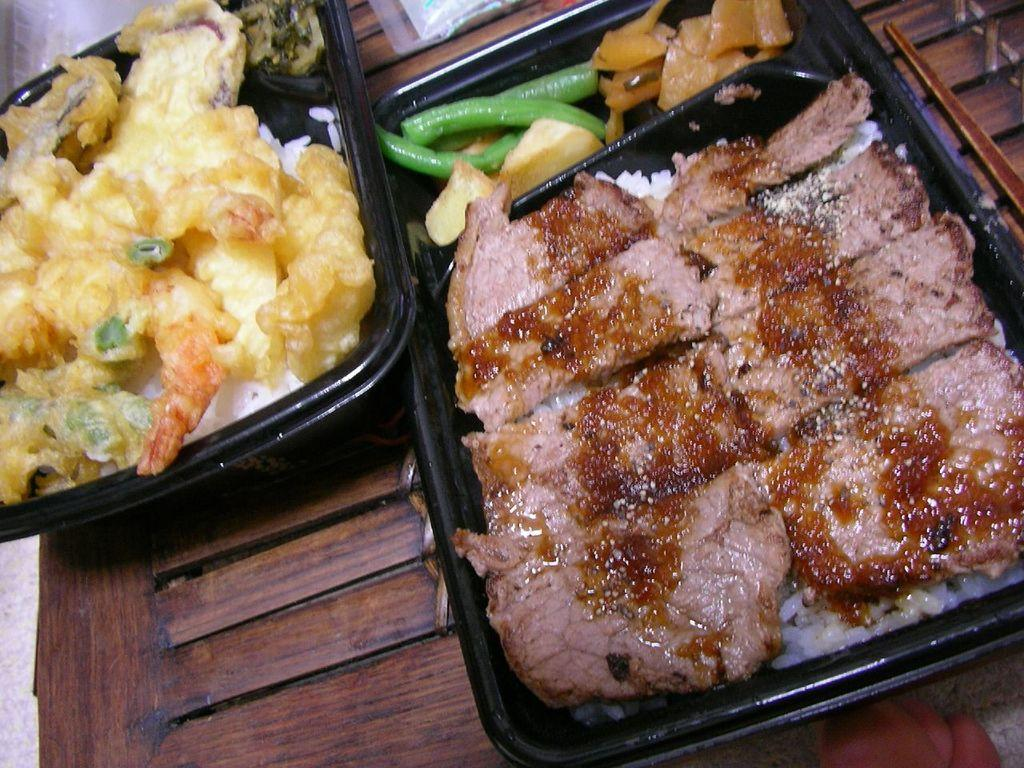What objects are in the foreground of the image? There are plastic boxes in the foreground of the image. What is inside the plastic boxes? The plastic boxes contain food items. What type of surface is the food placed on? The food items are placed on a wooden surface. How many slaves are depicted in the image? There are no slaves depicted in the image; it features plastic boxes containing food items placed on a wooden surface. 